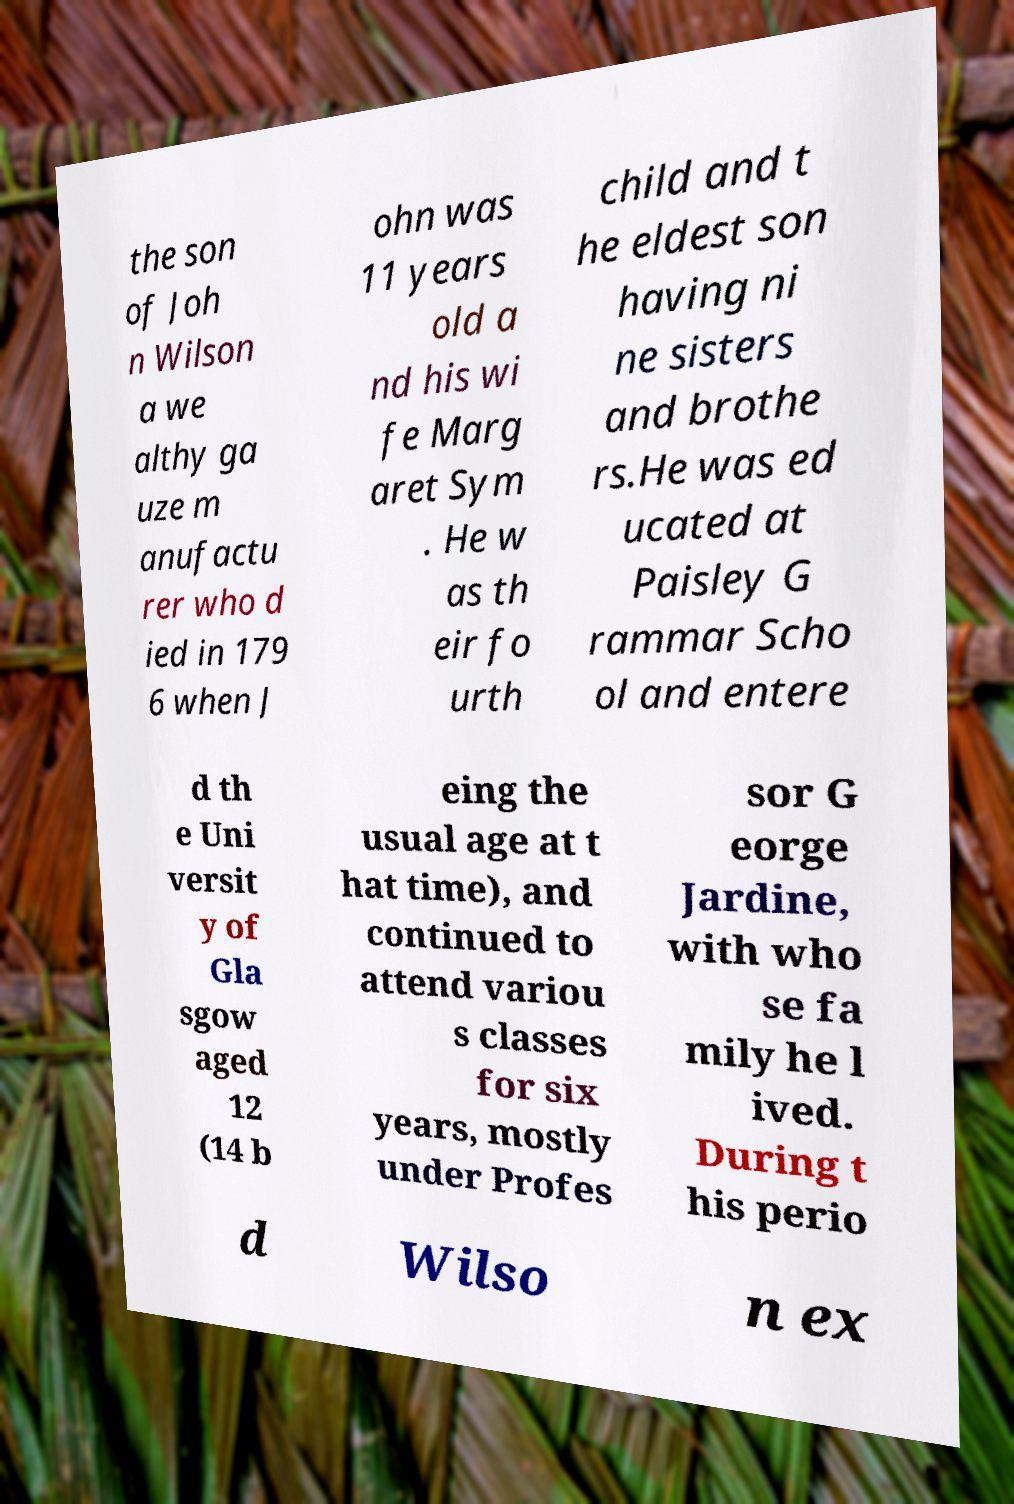For documentation purposes, I need the text within this image transcribed. Could you provide that? the son of Joh n Wilson a we althy ga uze m anufactu rer who d ied in 179 6 when J ohn was 11 years old a nd his wi fe Marg aret Sym . He w as th eir fo urth child and t he eldest son having ni ne sisters and brothe rs.He was ed ucated at Paisley G rammar Scho ol and entere d th e Uni versit y of Gla sgow aged 12 (14 b eing the usual age at t hat time), and continued to attend variou s classes for six years, mostly under Profes sor G eorge Jardine, with who se fa mily he l ived. During t his perio d Wilso n ex 